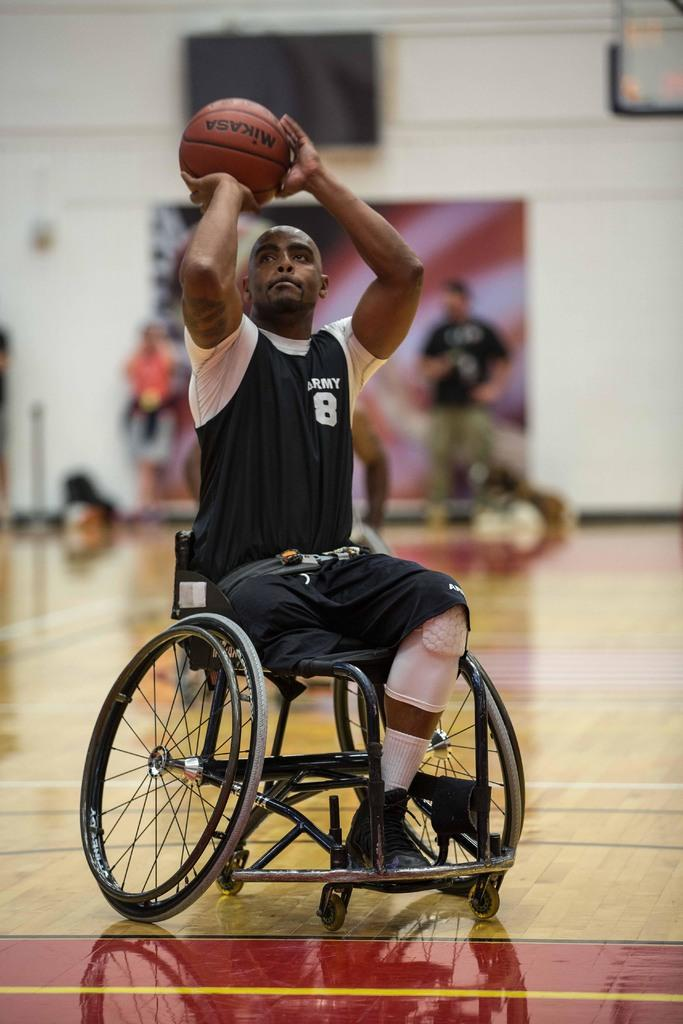What is the man in the image doing? The man is seated in a wheelchair in the image. What is the man holding in his hand? The man is holding a ball in his hand. Can you describe the people visible in the background of the image? There are people visible in the background of the image, but their specific actions or characteristics are not mentioned in the provided facts. What type of protest is taking place in the image? There is no protest present in the image; it features a man seated in a wheelchair holding a ball. What is the texture of the ball the man is holding? The texture of the ball is not mentioned in the provided facts, so it cannot be determined from the image. 